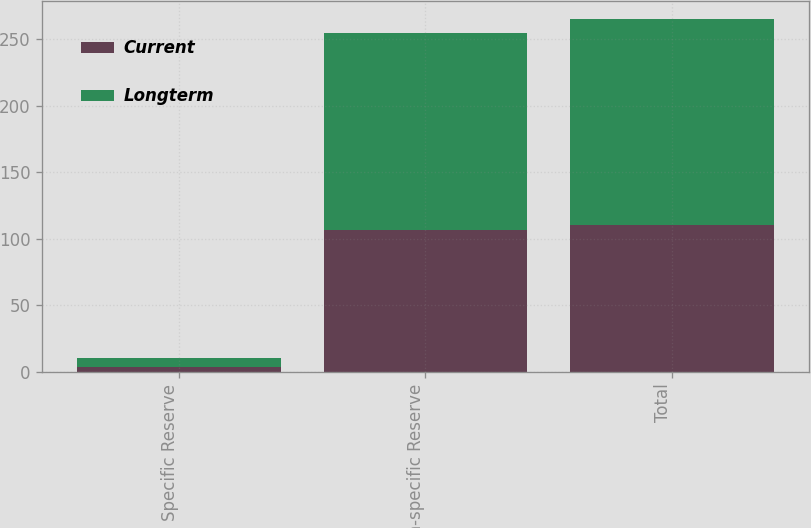<chart> <loc_0><loc_0><loc_500><loc_500><stacked_bar_chart><ecel><fcel>Specific Reserve<fcel>Non-specific Reserve<fcel>Total<nl><fcel>Current<fcel>3.8<fcel>106.5<fcel>110.3<nl><fcel>Longterm<fcel>6.6<fcel>148.4<fcel>155<nl></chart> 